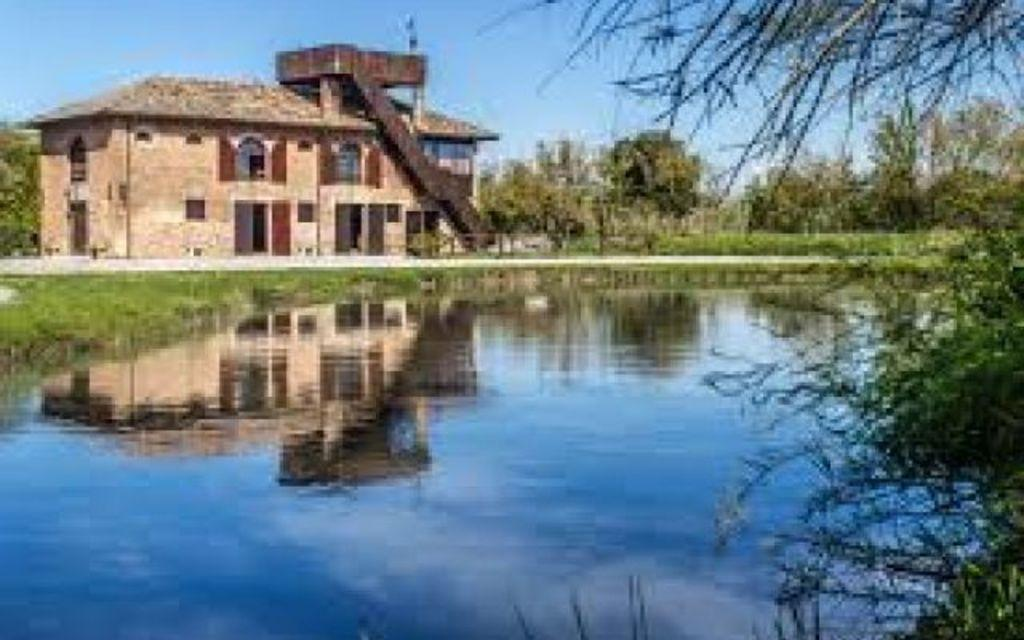What is the primary element visible in the image? There is water in the image. What type of vegetation can be seen in the image? There are trees in the image. What type of structure is present in the image? There is a house in the image. What can be seen in the background of the image? The sky is visible in the background of the image. Can you tell me what the faucet is saying in the image? There is no faucet present in the image, so it cannot be said what it might say. 